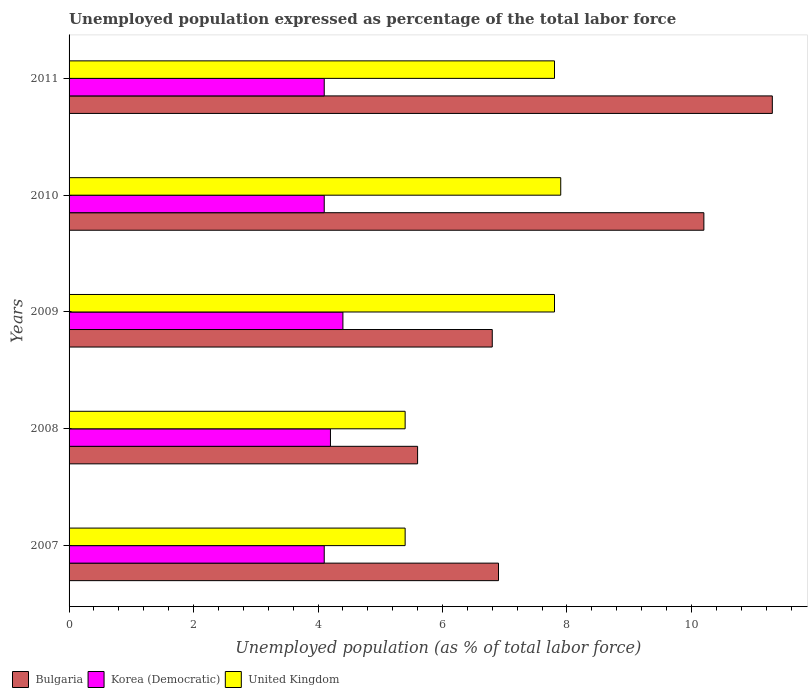How many bars are there on the 4th tick from the top?
Keep it short and to the point. 3. How many bars are there on the 4th tick from the bottom?
Provide a succinct answer. 3. What is the label of the 1st group of bars from the top?
Make the answer very short. 2011. In how many cases, is the number of bars for a given year not equal to the number of legend labels?
Offer a very short reply. 0. What is the unemployment in in United Kingdom in 2008?
Provide a succinct answer. 5.4. Across all years, what is the maximum unemployment in in Bulgaria?
Your response must be concise. 11.3. Across all years, what is the minimum unemployment in in Korea (Democratic)?
Give a very brief answer. 4.1. In which year was the unemployment in in Bulgaria maximum?
Your answer should be compact. 2011. What is the total unemployment in in United Kingdom in the graph?
Provide a succinct answer. 34.3. What is the difference between the unemployment in in Korea (Democratic) in 2007 and that in 2009?
Keep it short and to the point. -0.3. What is the difference between the unemployment in in Korea (Democratic) in 2008 and the unemployment in in Bulgaria in 2007?
Your answer should be very brief. -2.7. What is the average unemployment in in United Kingdom per year?
Give a very brief answer. 6.86. In the year 2007, what is the difference between the unemployment in in Korea (Democratic) and unemployment in in United Kingdom?
Provide a short and direct response. -1.3. In how many years, is the unemployment in in United Kingdom greater than 8.8 %?
Provide a succinct answer. 0. What is the ratio of the unemployment in in United Kingdom in 2008 to that in 2010?
Your response must be concise. 0.68. Is the unemployment in in United Kingdom in 2007 less than that in 2009?
Your answer should be compact. Yes. What is the difference between the highest and the second highest unemployment in in United Kingdom?
Your answer should be very brief. 0.1. What is the difference between the highest and the lowest unemployment in in United Kingdom?
Offer a terse response. 2.5. What does the 3rd bar from the top in 2010 represents?
Ensure brevity in your answer.  Bulgaria. How many bars are there?
Provide a succinct answer. 15. Are the values on the major ticks of X-axis written in scientific E-notation?
Your answer should be compact. No. Does the graph contain grids?
Your answer should be compact. No. What is the title of the graph?
Offer a terse response. Unemployed population expressed as percentage of the total labor force. What is the label or title of the X-axis?
Give a very brief answer. Unemployed population (as % of total labor force). What is the Unemployed population (as % of total labor force) in Bulgaria in 2007?
Your answer should be very brief. 6.9. What is the Unemployed population (as % of total labor force) in Korea (Democratic) in 2007?
Keep it short and to the point. 4.1. What is the Unemployed population (as % of total labor force) of United Kingdom in 2007?
Ensure brevity in your answer.  5.4. What is the Unemployed population (as % of total labor force) of Bulgaria in 2008?
Your response must be concise. 5.6. What is the Unemployed population (as % of total labor force) of Korea (Democratic) in 2008?
Offer a terse response. 4.2. What is the Unemployed population (as % of total labor force) in United Kingdom in 2008?
Your answer should be very brief. 5.4. What is the Unemployed population (as % of total labor force) in Bulgaria in 2009?
Keep it short and to the point. 6.8. What is the Unemployed population (as % of total labor force) in Korea (Democratic) in 2009?
Ensure brevity in your answer.  4.4. What is the Unemployed population (as % of total labor force) of United Kingdom in 2009?
Your answer should be compact. 7.8. What is the Unemployed population (as % of total labor force) of Bulgaria in 2010?
Make the answer very short. 10.2. What is the Unemployed population (as % of total labor force) of Korea (Democratic) in 2010?
Your answer should be very brief. 4.1. What is the Unemployed population (as % of total labor force) in United Kingdom in 2010?
Your answer should be very brief. 7.9. What is the Unemployed population (as % of total labor force) in Bulgaria in 2011?
Your answer should be very brief. 11.3. What is the Unemployed population (as % of total labor force) of Korea (Democratic) in 2011?
Provide a succinct answer. 4.1. What is the Unemployed population (as % of total labor force) in United Kingdom in 2011?
Offer a terse response. 7.8. Across all years, what is the maximum Unemployed population (as % of total labor force) of Bulgaria?
Your answer should be compact. 11.3. Across all years, what is the maximum Unemployed population (as % of total labor force) of Korea (Democratic)?
Provide a short and direct response. 4.4. Across all years, what is the maximum Unemployed population (as % of total labor force) in United Kingdom?
Your answer should be very brief. 7.9. Across all years, what is the minimum Unemployed population (as % of total labor force) in Bulgaria?
Your response must be concise. 5.6. Across all years, what is the minimum Unemployed population (as % of total labor force) in Korea (Democratic)?
Provide a succinct answer. 4.1. Across all years, what is the minimum Unemployed population (as % of total labor force) in United Kingdom?
Keep it short and to the point. 5.4. What is the total Unemployed population (as % of total labor force) in Bulgaria in the graph?
Offer a very short reply. 40.8. What is the total Unemployed population (as % of total labor force) of Korea (Democratic) in the graph?
Keep it short and to the point. 20.9. What is the total Unemployed population (as % of total labor force) in United Kingdom in the graph?
Offer a terse response. 34.3. What is the difference between the Unemployed population (as % of total labor force) of Bulgaria in 2007 and that in 2008?
Offer a terse response. 1.3. What is the difference between the Unemployed population (as % of total labor force) of Korea (Democratic) in 2007 and that in 2008?
Provide a succinct answer. -0.1. What is the difference between the Unemployed population (as % of total labor force) in United Kingdom in 2007 and that in 2009?
Offer a very short reply. -2.4. What is the difference between the Unemployed population (as % of total labor force) of Bulgaria in 2007 and that in 2010?
Offer a very short reply. -3.3. What is the difference between the Unemployed population (as % of total labor force) in Korea (Democratic) in 2007 and that in 2011?
Offer a terse response. 0. What is the difference between the Unemployed population (as % of total labor force) of Bulgaria in 2008 and that in 2009?
Make the answer very short. -1.2. What is the difference between the Unemployed population (as % of total labor force) in Korea (Democratic) in 2008 and that in 2009?
Make the answer very short. -0.2. What is the difference between the Unemployed population (as % of total labor force) in Bulgaria in 2008 and that in 2010?
Provide a succinct answer. -4.6. What is the difference between the Unemployed population (as % of total labor force) in Korea (Democratic) in 2008 and that in 2010?
Give a very brief answer. 0.1. What is the difference between the Unemployed population (as % of total labor force) in Bulgaria in 2008 and that in 2011?
Your response must be concise. -5.7. What is the difference between the Unemployed population (as % of total labor force) of Bulgaria in 2009 and that in 2010?
Ensure brevity in your answer.  -3.4. What is the difference between the Unemployed population (as % of total labor force) in Bulgaria in 2009 and that in 2011?
Your answer should be very brief. -4.5. What is the difference between the Unemployed population (as % of total labor force) in Bulgaria in 2010 and that in 2011?
Your response must be concise. -1.1. What is the difference between the Unemployed population (as % of total labor force) in United Kingdom in 2010 and that in 2011?
Your answer should be very brief. 0.1. What is the difference between the Unemployed population (as % of total labor force) of Bulgaria in 2007 and the Unemployed population (as % of total labor force) of United Kingdom in 2008?
Make the answer very short. 1.5. What is the difference between the Unemployed population (as % of total labor force) in Korea (Democratic) in 2007 and the Unemployed population (as % of total labor force) in United Kingdom in 2008?
Give a very brief answer. -1.3. What is the difference between the Unemployed population (as % of total labor force) of Bulgaria in 2007 and the Unemployed population (as % of total labor force) of United Kingdom in 2009?
Give a very brief answer. -0.9. What is the difference between the Unemployed population (as % of total labor force) of Bulgaria in 2007 and the Unemployed population (as % of total labor force) of Korea (Democratic) in 2010?
Your answer should be compact. 2.8. What is the difference between the Unemployed population (as % of total labor force) of Korea (Democratic) in 2007 and the Unemployed population (as % of total labor force) of United Kingdom in 2010?
Offer a very short reply. -3.8. What is the difference between the Unemployed population (as % of total labor force) in Bulgaria in 2007 and the Unemployed population (as % of total labor force) in Korea (Democratic) in 2011?
Your answer should be very brief. 2.8. What is the difference between the Unemployed population (as % of total labor force) in Bulgaria in 2007 and the Unemployed population (as % of total labor force) in United Kingdom in 2011?
Offer a terse response. -0.9. What is the difference between the Unemployed population (as % of total labor force) of Korea (Democratic) in 2007 and the Unemployed population (as % of total labor force) of United Kingdom in 2011?
Make the answer very short. -3.7. What is the difference between the Unemployed population (as % of total labor force) in Korea (Democratic) in 2008 and the Unemployed population (as % of total labor force) in United Kingdom in 2009?
Give a very brief answer. -3.6. What is the difference between the Unemployed population (as % of total labor force) in Bulgaria in 2008 and the Unemployed population (as % of total labor force) in Korea (Democratic) in 2010?
Your answer should be compact. 1.5. What is the difference between the Unemployed population (as % of total labor force) of Bulgaria in 2008 and the Unemployed population (as % of total labor force) of United Kingdom in 2010?
Your response must be concise. -2.3. What is the difference between the Unemployed population (as % of total labor force) of Bulgaria in 2008 and the Unemployed population (as % of total labor force) of Korea (Democratic) in 2011?
Provide a short and direct response. 1.5. What is the difference between the Unemployed population (as % of total labor force) in Bulgaria in 2008 and the Unemployed population (as % of total labor force) in United Kingdom in 2011?
Offer a very short reply. -2.2. What is the difference between the Unemployed population (as % of total labor force) of Bulgaria in 2009 and the Unemployed population (as % of total labor force) of Korea (Democratic) in 2010?
Your response must be concise. 2.7. What is the difference between the Unemployed population (as % of total labor force) of Korea (Democratic) in 2009 and the Unemployed population (as % of total labor force) of United Kingdom in 2010?
Your response must be concise. -3.5. What is the difference between the Unemployed population (as % of total labor force) in Bulgaria in 2009 and the Unemployed population (as % of total labor force) in Korea (Democratic) in 2011?
Your response must be concise. 2.7. What is the difference between the Unemployed population (as % of total labor force) of Bulgaria in 2010 and the Unemployed population (as % of total labor force) of United Kingdom in 2011?
Your answer should be compact. 2.4. What is the average Unemployed population (as % of total labor force) of Bulgaria per year?
Your answer should be compact. 8.16. What is the average Unemployed population (as % of total labor force) of Korea (Democratic) per year?
Give a very brief answer. 4.18. What is the average Unemployed population (as % of total labor force) in United Kingdom per year?
Offer a terse response. 6.86. In the year 2007, what is the difference between the Unemployed population (as % of total labor force) of Bulgaria and Unemployed population (as % of total labor force) of United Kingdom?
Give a very brief answer. 1.5. In the year 2007, what is the difference between the Unemployed population (as % of total labor force) in Korea (Democratic) and Unemployed population (as % of total labor force) in United Kingdom?
Give a very brief answer. -1.3. In the year 2008, what is the difference between the Unemployed population (as % of total labor force) of Bulgaria and Unemployed population (as % of total labor force) of Korea (Democratic)?
Keep it short and to the point. 1.4. In the year 2008, what is the difference between the Unemployed population (as % of total labor force) of Bulgaria and Unemployed population (as % of total labor force) of United Kingdom?
Your answer should be very brief. 0.2. In the year 2010, what is the difference between the Unemployed population (as % of total labor force) of Bulgaria and Unemployed population (as % of total labor force) of Korea (Democratic)?
Your response must be concise. 6.1. In the year 2010, what is the difference between the Unemployed population (as % of total labor force) of Bulgaria and Unemployed population (as % of total labor force) of United Kingdom?
Give a very brief answer. 2.3. In the year 2011, what is the difference between the Unemployed population (as % of total labor force) in Korea (Democratic) and Unemployed population (as % of total labor force) in United Kingdom?
Keep it short and to the point. -3.7. What is the ratio of the Unemployed population (as % of total labor force) in Bulgaria in 2007 to that in 2008?
Your answer should be compact. 1.23. What is the ratio of the Unemployed population (as % of total labor force) of Korea (Democratic) in 2007 to that in 2008?
Make the answer very short. 0.98. What is the ratio of the Unemployed population (as % of total labor force) in United Kingdom in 2007 to that in 2008?
Keep it short and to the point. 1. What is the ratio of the Unemployed population (as % of total labor force) in Bulgaria in 2007 to that in 2009?
Your answer should be very brief. 1.01. What is the ratio of the Unemployed population (as % of total labor force) in Korea (Democratic) in 2007 to that in 2009?
Your answer should be compact. 0.93. What is the ratio of the Unemployed population (as % of total labor force) in United Kingdom in 2007 to that in 2009?
Offer a terse response. 0.69. What is the ratio of the Unemployed population (as % of total labor force) in Bulgaria in 2007 to that in 2010?
Make the answer very short. 0.68. What is the ratio of the Unemployed population (as % of total labor force) in United Kingdom in 2007 to that in 2010?
Keep it short and to the point. 0.68. What is the ratio of the Unemployed population (as % of total labor force) of Bulgaria in 2007 to that in 2011?
Offer a very short reply. 0.61. What is the ratio of the Unemployed population (as % of total labor force) in Korea (Democratic) in 2007 to that in 2011?
Offer a terse response. 1. What is the ratio of the Unemployed population (as % of total labor force) of United Kingdom in 2007 to that in 2011?
Offer a terse response. 0.69. What is the ratio of the Unemployed population (as % of total labor force) of Bulgaria in 2008 to that in 2009?
Your response must be concise. 0.82. What is the ratio of the Unemployed population (as % of total labor force) in Korea (Democratic) in 2008 to that in 2009?
Ensure brevity in your answer.  0.95. What is the ratio of the Unemployed population (as % of total labor force) in United Kingdom in 2008 to that in 2009?
Your answer should be very brief. 0.69. What is the ratio of the Unemployed population (as % of total labor force) in Bulgaria in 2008 to that in 2010?
Provide a short and direct response. 0.55. What is the ratio of the Unemployed population (as % of total labor force) in Korea (Democratic) in 2008 to that in 2010?
Keep it short and to the point. 1.02. What is the ratio of the Unemployed population (as % of total labor force) in United Kingdom in 2008 to that in 2010?
Provide a succinct answer. 0.68. What is the ratio of the Unemployed population (as % of total labor force) of Bulgaria in 2008 to that in 2011?
Your answer should be compact. 0.5. What is the ratio of the Unemployed population (as % of total labor force) in Korea (Democratic) in 2008 to that in 2011?
Offer a terse response. 1.02. What is the ratio of the Unemployed population (as % of total labor force) in United Kingdom in 2008 to that in 2011?
Keep it short and to the point. 0.69. What is the ratio of the Unemployed population (as % of total labor force) of Korea (Democratic) in 2009 to that in 2010?
Your answer should be very brief. 1.07. What is the ratio of the Unemployed population (as % of total labor force) of United Kingdom in 2009 to that in 2010?
Your response must be concise. 0.99. What is the ratio of the Unemployed population (as % of total labor force) of Bulgaria in 2009 to that in 2011?
Your answer should be very brief. 0.6. What is the ratio of the Unemployed population (as % of total labor force) in Korea (Democratic) in 2009 to that in 2011?
Offer a very short reply. 1.07. What is the ratio of the Unemployed population (as % of total labor force) of United Kingdom in 2009 to that in 2011?
Your answer should be compact. 1. What is the ratio of the Unemployed population (as % of total labor force) in Bulgaria in 2010 to that in 2011?
Provide a short and direct response. 0.9. What is the ratio of the Unemployed population (as % of total labor force) of Korea (Democratic) in 2010 to that in 2011?
Make the answer very short. 1. What is the ratio of the Unemployed population (as % of total labor force) of United Kingdom in 2010 to that in 2011?
Your answer should be very brief. 1.01. What is the difference between the highest and the second highest Unemployed population (as % of total labor force) of Korea (Democratic)?
Provide a succinct answer. 0.2. What is the difference between the highest and the second highest Unemployed population (as % of total labor force) of United Kingdom?
Make the answer very short. 0.1. What is the difference between the highest and the lowest Unemployed population (as % of total labor force) of Korea (Democratic)?
Give a very brief answer. 0.3. 